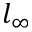Convert formula to latex. <formula><loc_0><loc_0><loc_500><loc_500>l _ { \infty }</formula> 